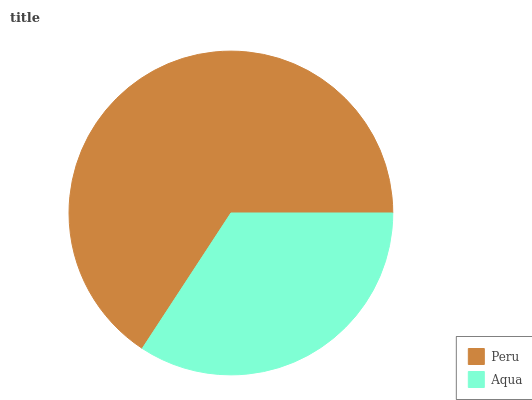Is Aqua the minimum?
Answer yes or no. Yes. Is Peru the maximum?
Answer yes or no. Yes. Is Aqua the maximum?
Answer yes or no. No. Is Peru greater than Aqua?
Answer yes or no. Yes. Is Aqua less than Peru?
Answer yes or no. Yes. Is Aqua greater than Peru?
Answer yes or no. No. Is Peru less than Aqua?
Answer yes or no. No. Is Peru the high median?
Answer yes or no. Yes. Is Aqua the low median?
Answer yes or no. Yes. Is Aqua the high median?
Answer yes or no. No. Is Peru the low median?
Answer yes or no. No. 